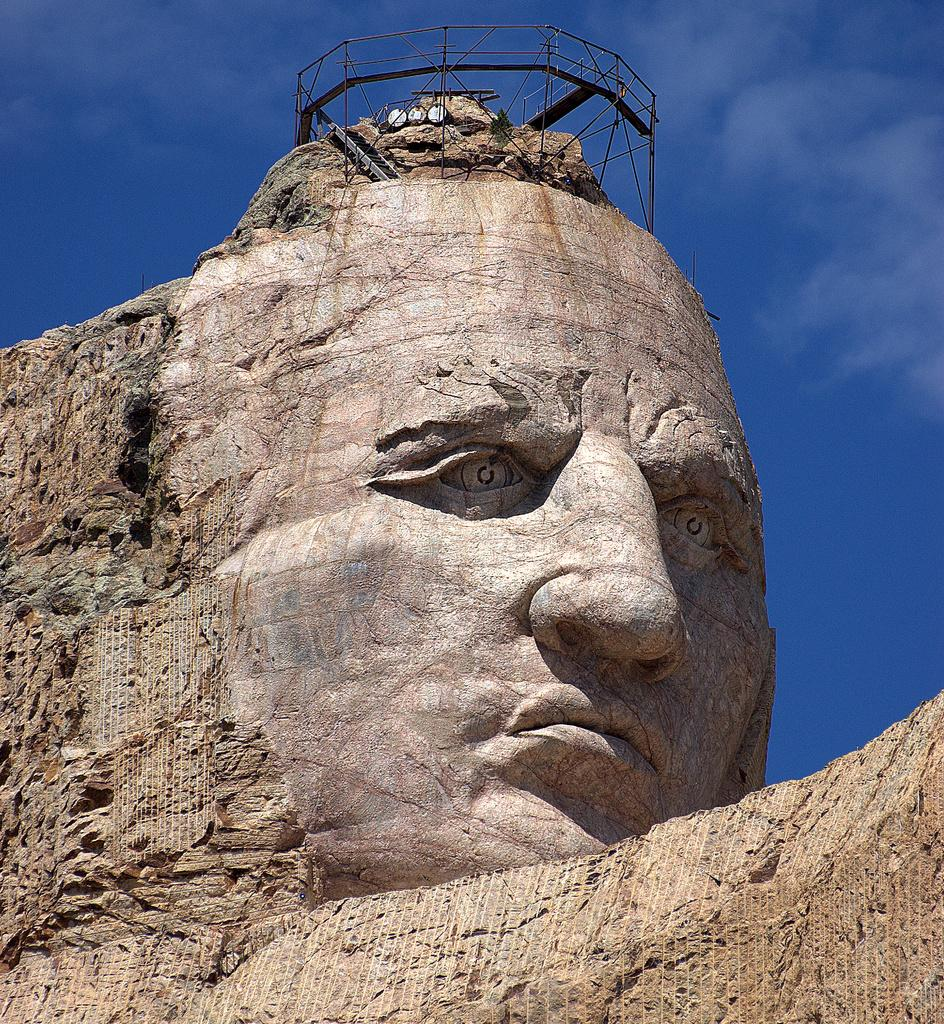What type of artwork is present in the image? There is a human sculpture in the image. What can be seen at the top of the image? There is a fence at the top of the image. What part of the natural environment is visible in the image? The sky is visible in the image. How many balls are being juggled by the human sculpture in the image? There are no balls present in the image; it features a human sculpture and a fence. How long does it take for the finger to complete a full rotation in the image? There is no finger present in the image, so it is not possible to determine the time it takes for a rotation. 